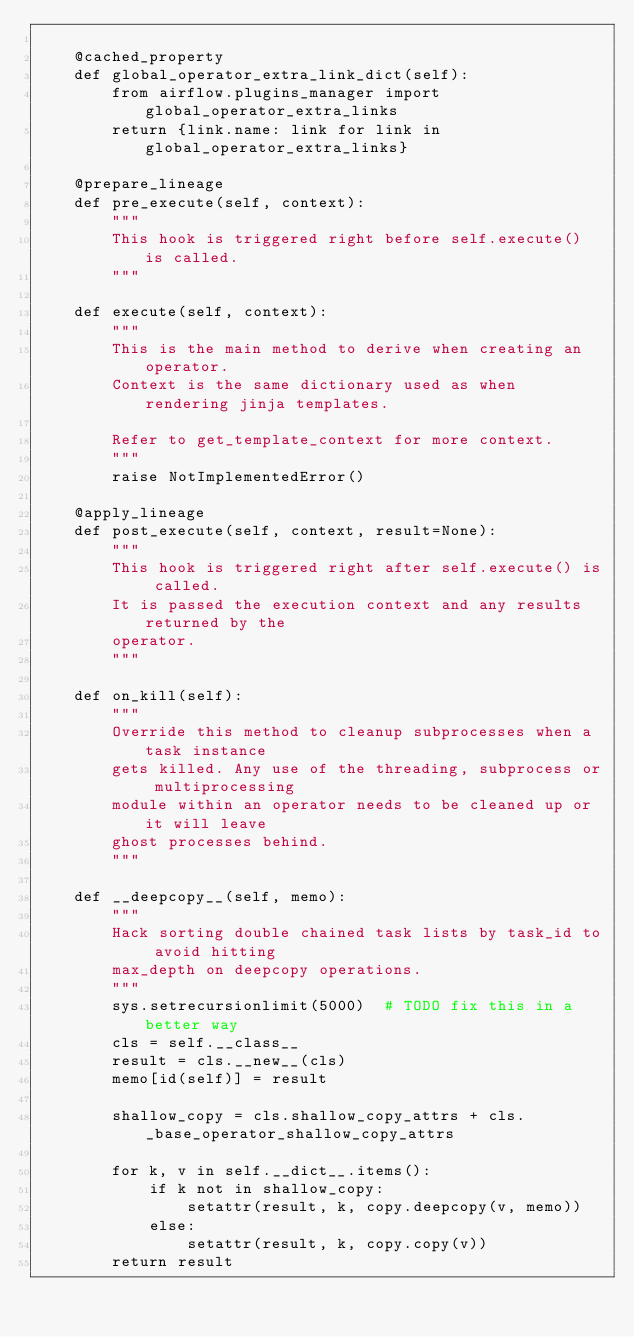<code> <loc_0><loc_0><loc_500><loc_500><_Python_>
    @cached_property
    def global_operator_extra_link_dict(self):
        from airflow.plugins_manager import global_operator_extra_links
        return {link.name: link for link in global_operator_extra_links}

    @prepare_lineage
    def pre_execute(self, context):
        """
        This hook is triggered right before self.execute() is called.
        """

    def execute(self, context):
        """
        This is the main method to derive when creating an operator.
        Context is the same dictionary used as when rendering jinja templates.

        Refer to get_template_context for more context.
        """
        raise NotImplementedError()

    @apply_lineage
    def post_execute(self, context, result=None):
        """
        This hook is triggered right after self.execute() is called.
        It is passed the execution context and any results returned by the
        operator.
        """

    def on_kill(self):
        """
        Override this method to cleanup subprocesses when a task instance
        gets killed. Any use of the threading, subprocess or multiprocessing
        module within an operator needs to be cleaned up or it will leave
        ghost processes behind.
        """

    def __deepcopy__(self, memo):
        """
        Hack sorting double chained task lists by task_id to avoid hitting
        max_depth on deepcopy operations.
        """
        sys.setrecursionlimit(5000)  # TODO fix this in a better way
        cls = self.__class__
        result = cls.__new__(cls)
        memo[id(self)] = result

        shallow_copy = cls.shallow_copy_attrs + cls._base_operator_shallow_copy_attrs

        for k, v in self.__dict__.items():
            if k not in shallow_copy:
                setattr(result, k, copy.deepcopy(v, memo))
            else:
                setattr(result, k, copy.copy(v))
        return result
</code> 